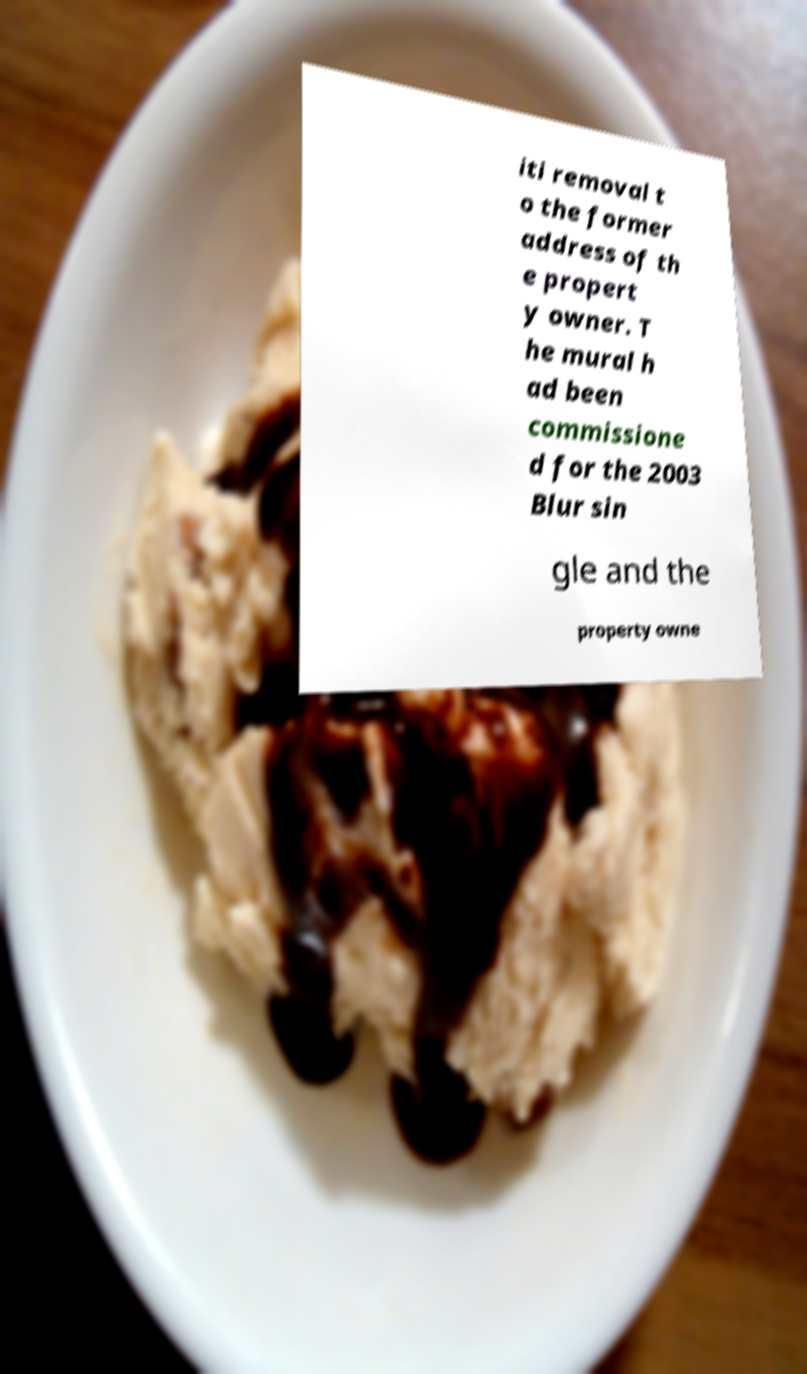Please read and relay the text visible in this image. What does it say? iti removal t o the former address of th e propert y owner. T he mural h ad been commissione d for the 2003 Blur sin gle and the property owne 